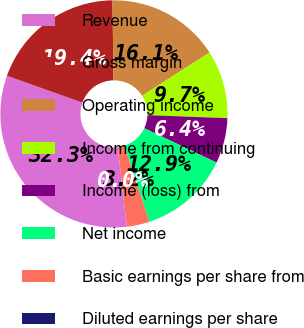Convert chart to OTSL. <chart><loc_0><loc_0><loc_500><loc_500><pie_chart><fcel>Revenue<fcel>Gross margin<fcel>Operating income<fcel>Income from continuing<fcel>Income (loss) from<fcel>Net income<fcel>Basic earnings per share from<fcel>Diluted earnings per share<nl><fcel>32.26%<fcel>19.35%<fcel>16.13%<fcel>9.68%<fcel>6.45%<fcel>12.9%<fcel>3.23%<fcel>0.0%<nl></chart> 